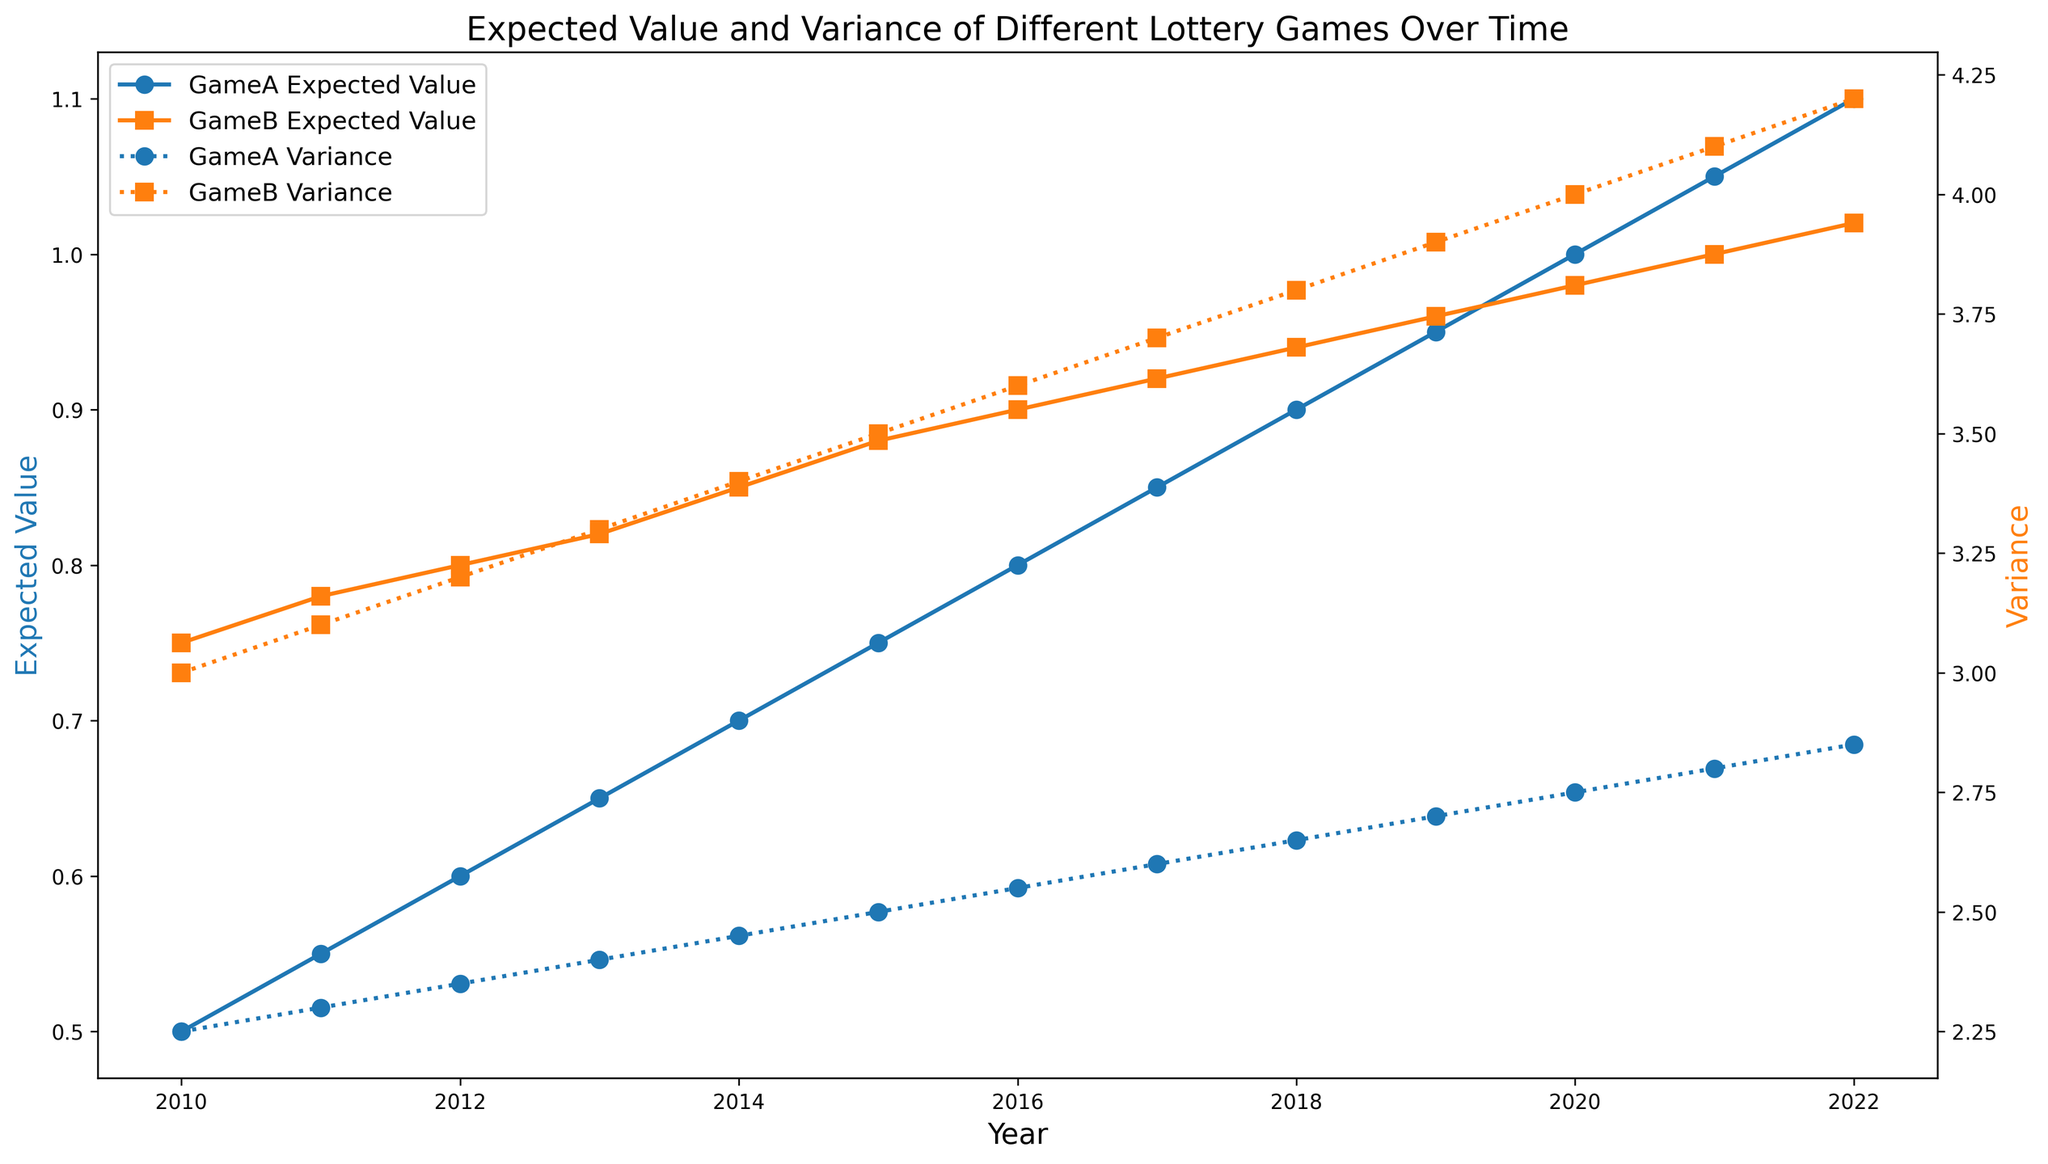Which game has a higher expected value in 2020? To determine which game has the higher expected value in 2020, we need to compare the expected values of GameA and GameB in that year. The plot shows that in 2020, GameA has an expected value of 1.00, while GameB has an expected value of 0.98.
Answer: GameA How does the variance of GameB compare to GameA in 2015? To compare the variance between the two games in 2015, look at the variances for each game in that year. GameA has a variance of 2.50, and GameB has a variance of 3.50. Thus, the variance of GameB is greater than that of GameA.
Answer: GameB's variance is higher What is the difference in expected value between GameA and GameB in 2011? To find the difference, subtract the expected value of GameA from that of GameB in 2011. The expected values are 0.55 for GameA and 0.78 for GameB. The difference is 0.78 - 0.55 = 0.23.
Answer: 0.23 By how much did the expected value of GameA increase from 2017 to 2022? Subtract the expected value of GameA in 2017 from its value in 2022. The expected values are 0.85 in 2017 and 1.10 in 2022. The increase is 1.10 - 0.85 = 0.25.
Answer: 0.25 In which year do GameA and GameB have the closest expected value? To find the year with the closest expected values, look for the smallest difference between the expected values for each year. The closest values are 1.05 for GameA and 1.00 for GameB in 2021, with a difference of 0.05.
Answer: 2021 What is the percentage increase in variance for GameB from 2014 to 2019? Calculate the percentage increase by using the formula: ((Variance in 2019 - Variance in 2014) / Variance in 2014) x 100. Variances are 3.90 in 2019 and 3.40 in 2014. The increase is ((3.90 - 3.40) / 3.40) x 100 = 14.7%.
Answer: 14.7% Which game shows a more consistent increase in expected value from 2010 to 2022? Determine the consistency of the increase by visually inspecting the lines for smoothness and regularity. Both games show smooth increases, but GameA's increase is more linear without fluctuations.
Answer: GameA What trends are observable in the variances of both games over time? Analyze the trend lines for variance. Both games show an increasing trend in variance, with GameB's variance increasing more sharply compared to GameA's variance.
Answer: Increasing trend for both; sharper for GameB What is the average expected value of GameA over the entire period? Calculate the average by summing the expected values of GameA from 2010 to 2022 and dividing by the number of years. Total expected value is (0.50 + 0.55 + 0.60 + 0.65 + 0.70 + 0.75 + 0.80 + 0.85 + 0.90 + 0.95 + 1.00 + 1.05 + 1.10) = 9.40. There are 13 years, so average is 9.40 / 13 ≈ 0.72.
Answer: 0.72 Is there any year where GameB's variance is exactly twice that of GameA? Compare GameB's variances to twice the corresponding variances of GameA for each year. In 2021, GameA's variance is 2.80, and GameB's variance is 4.10. 2 * 2.80 = 5.60, which is not equal to 4.10. Therefore, there is no year where this condition is met.
Answer: No 